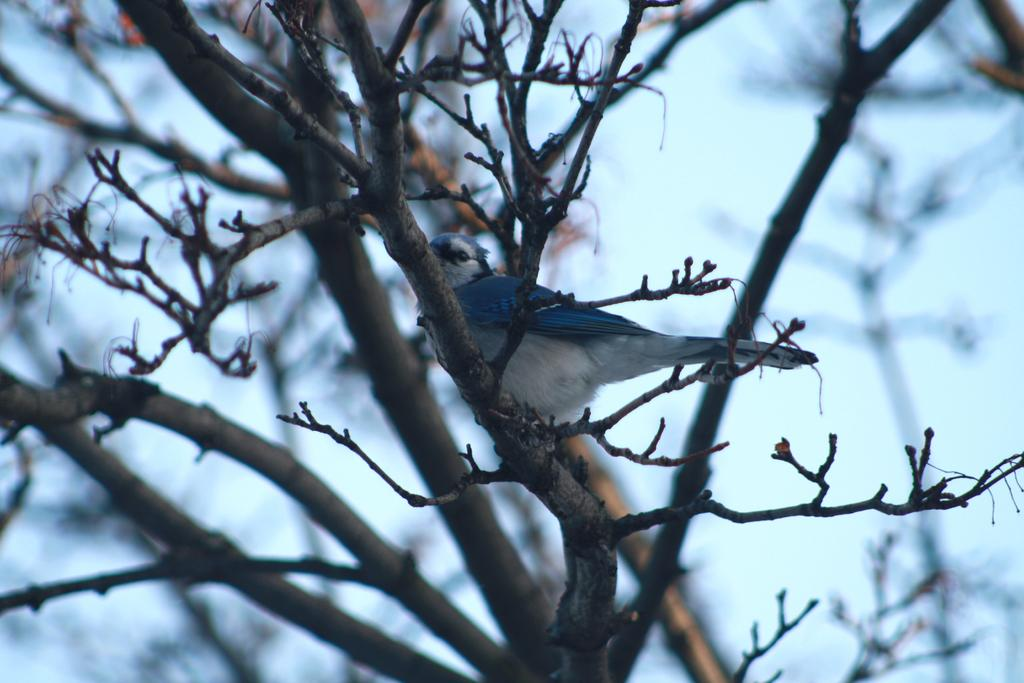What type of animal can be seen in the image? There is a bird in the image. Where is the bird located? The bird is on a branch in the image. What else can be seen in the image besides the bird? There are branches visible in the image. How would you describe the background of the image? The background of the image is blurred. What type of hair can be seen on the bird in the image? There is no hair visible on the bird in the image; it is a bird, not a mammal. 